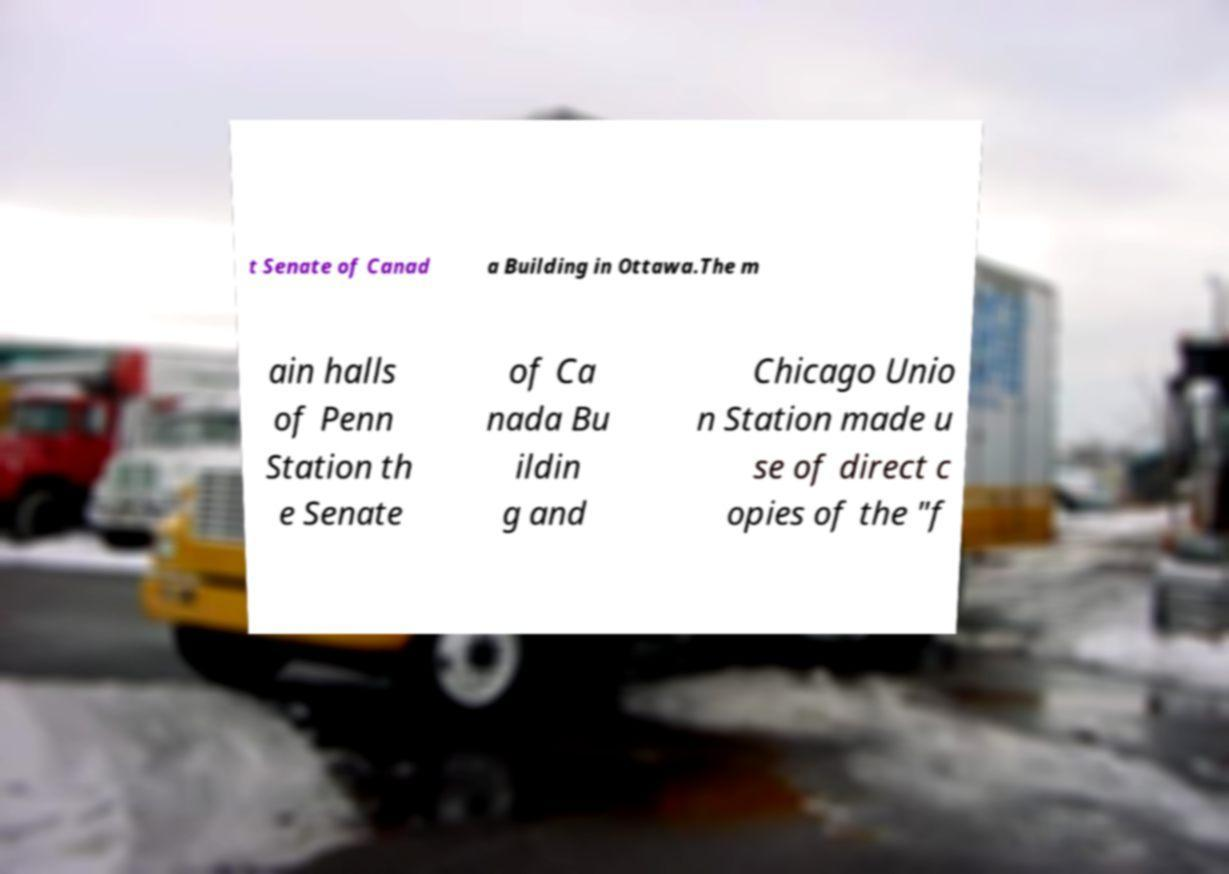Please read and relay the text visible in this image. What does it say? t Senate of Canad a Building in Ottawa.The m ain halls of Penn Station th e Senate of Ca nada Bu ildin g and Chicago Unio n Station made u se of direct c opies of the "f 